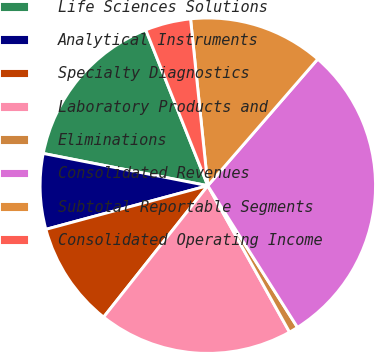Convert chart. <chart><loc_0><loc_0><loc_500><loc_500><pie_chart><fcel>Life Sciences Solutions<fcel>Analytical Instruments<fcel>Specialty Diagnostics<fcel>Laboratory Products and<fcel>Eliminations<fcel>Consolidated Revenues<fcel>Subtotal Reportable Segments<fcel>Consolidated Operating Income<nl><fcel>15.89%<fcel>7.27%<fcel>10.14%<fcel>18.77%<fcel>0.88%<fcel>29.64%<fcel>13.02%<fcel>4.39%<nl></chart> 